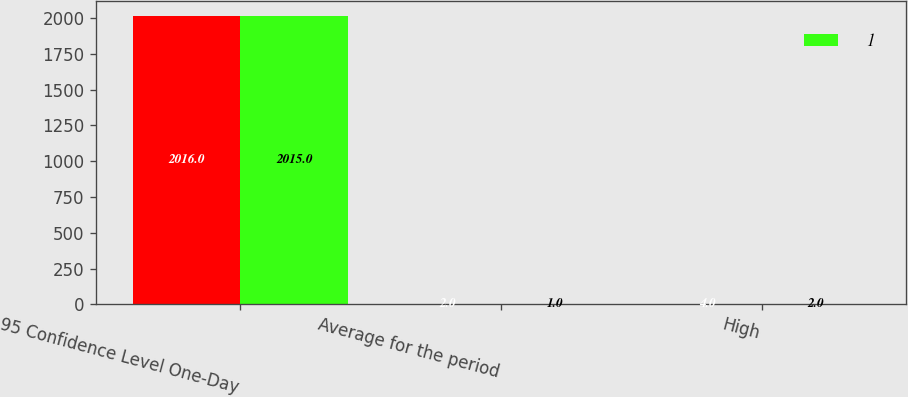<chart> <loc_0><loc_0><loc_500><loc_500><stacked_bar_chart><ecel><fcel>95 Confidence Level One-Day<fcel>Average for the period<fcel>High<nl><fcel>nan<fcel>2016<fcel>2<fcel>4<nl><fcel>1<fcel>2015<fcel>1<fcel>2<nl></chart> 